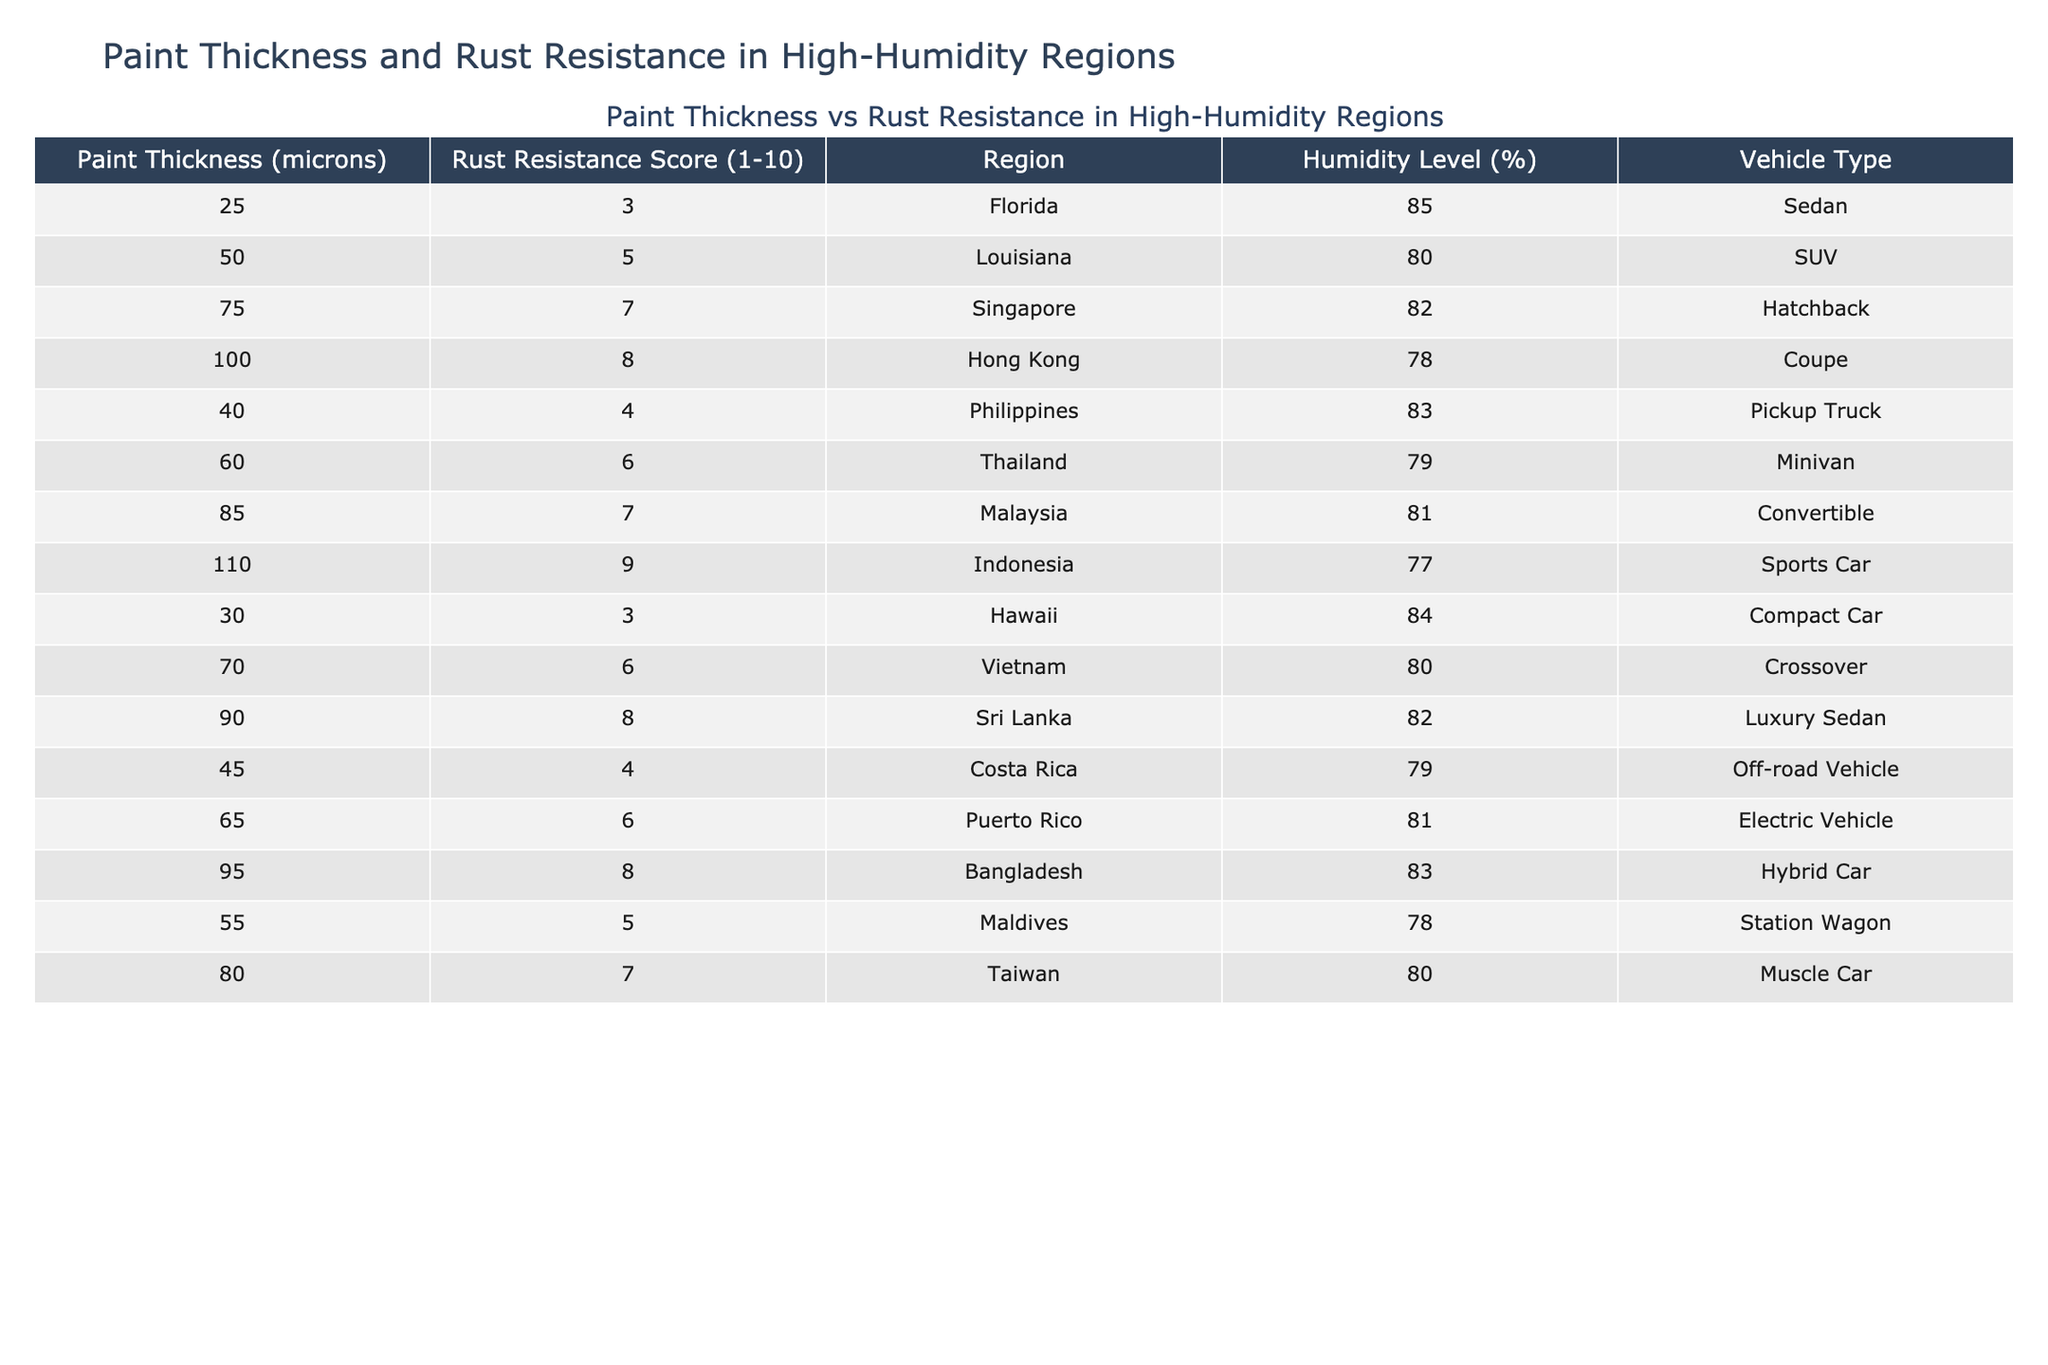What is the rust resistance score for the vehicle with a paint thickness of 100 microns? By locating the row with a paint thickness of 100 microns in the table, we see that the rust resistance score for this specific vehicle is 8.
Answer: 8 What is the average paint thickness of the vehicles listed in the table? To calculate the average, sum all the paint thickness values: 25 + 50 + 75 + 100 + 40 + 60 + 85 + 110 + 30 + 70 + 90 + 45 + 65 + 95 + 55 + 80 =  1055. Then divide by the total number of vehicles (16) to get the average: 1055 / 16 = 65.94.
Answer: 65.94 Is there any vehicle type with a rust resistance score of 10? Reviewing the table, none of the vehicles listed have a rust resistance score higher than 9, which indicates that there is no vehicle type that scored a 10.
Answer: No Which humidity level corresponds to the vehicle type "Sports Car"? From the table, we find the row for "Sports Car", which shows that the humidity level for this vehicle is 77%.
Answer: 77% What is the total rust resistance score for all vehicles with a paint thickness greater than 70 microns? We identify the vehicles with a paint thickness greater than 70 microns: 75 (7), 100 (8), 85 (7), 110 (9), 90 (8) which gives us: 7 + 8 + 7 + 9 + 8 = 39.
Answer: 39 What is the trend observable in rust resistance scores as paint thickness increases among these vehicles? By analyzing the rust resistance scores alongside increasing paint thickness, we notice a tendency for higher paint thickness (especially above 70 microns) to correlate with higher rust resistance scores, generally increasing as thickness increases.
Answer: Increasing trend Are there more vehicles with a paint thickness below 50 microns or above that value? Counting the vehicles, there are 6 with a paint thickness below 50 microns (25, 40, 30) and 10 with a thickness above 50 microns (50, 75, 100, 60, 85, 110, 70, 90, 95, 80). Therefore, there are more vehicles above 50 microns.
Answer: Above 50 microns What humidity level is shared by the maximum number of vehicle types in this table? Reviewing the humidity levels for each vehicle, 80% appears three times (Louisiana, Taiwan, and Vietnam), making it the most common among the listed vehicles.
Answer: 80% What is the difference in rust resistance score between the vehicle with the highest thickness and the one with the lowest? The vehicle with the highest thickness (110 microns) has a rust resistance score of 9, whereas the one with the lowest thickness (25 microns) has a score of 3. Thus, the difference is 9 - 3 = 6.
Answer: 6 How many vehicle types have a rust resistance score of 7 or higher? By examining the scores, we find there are 6 vehicle types with scores of 7 or higher (75, 100, 85, 90, 80, 110). Therefore, the total number of vehicle types is 6.
Answer: 6 